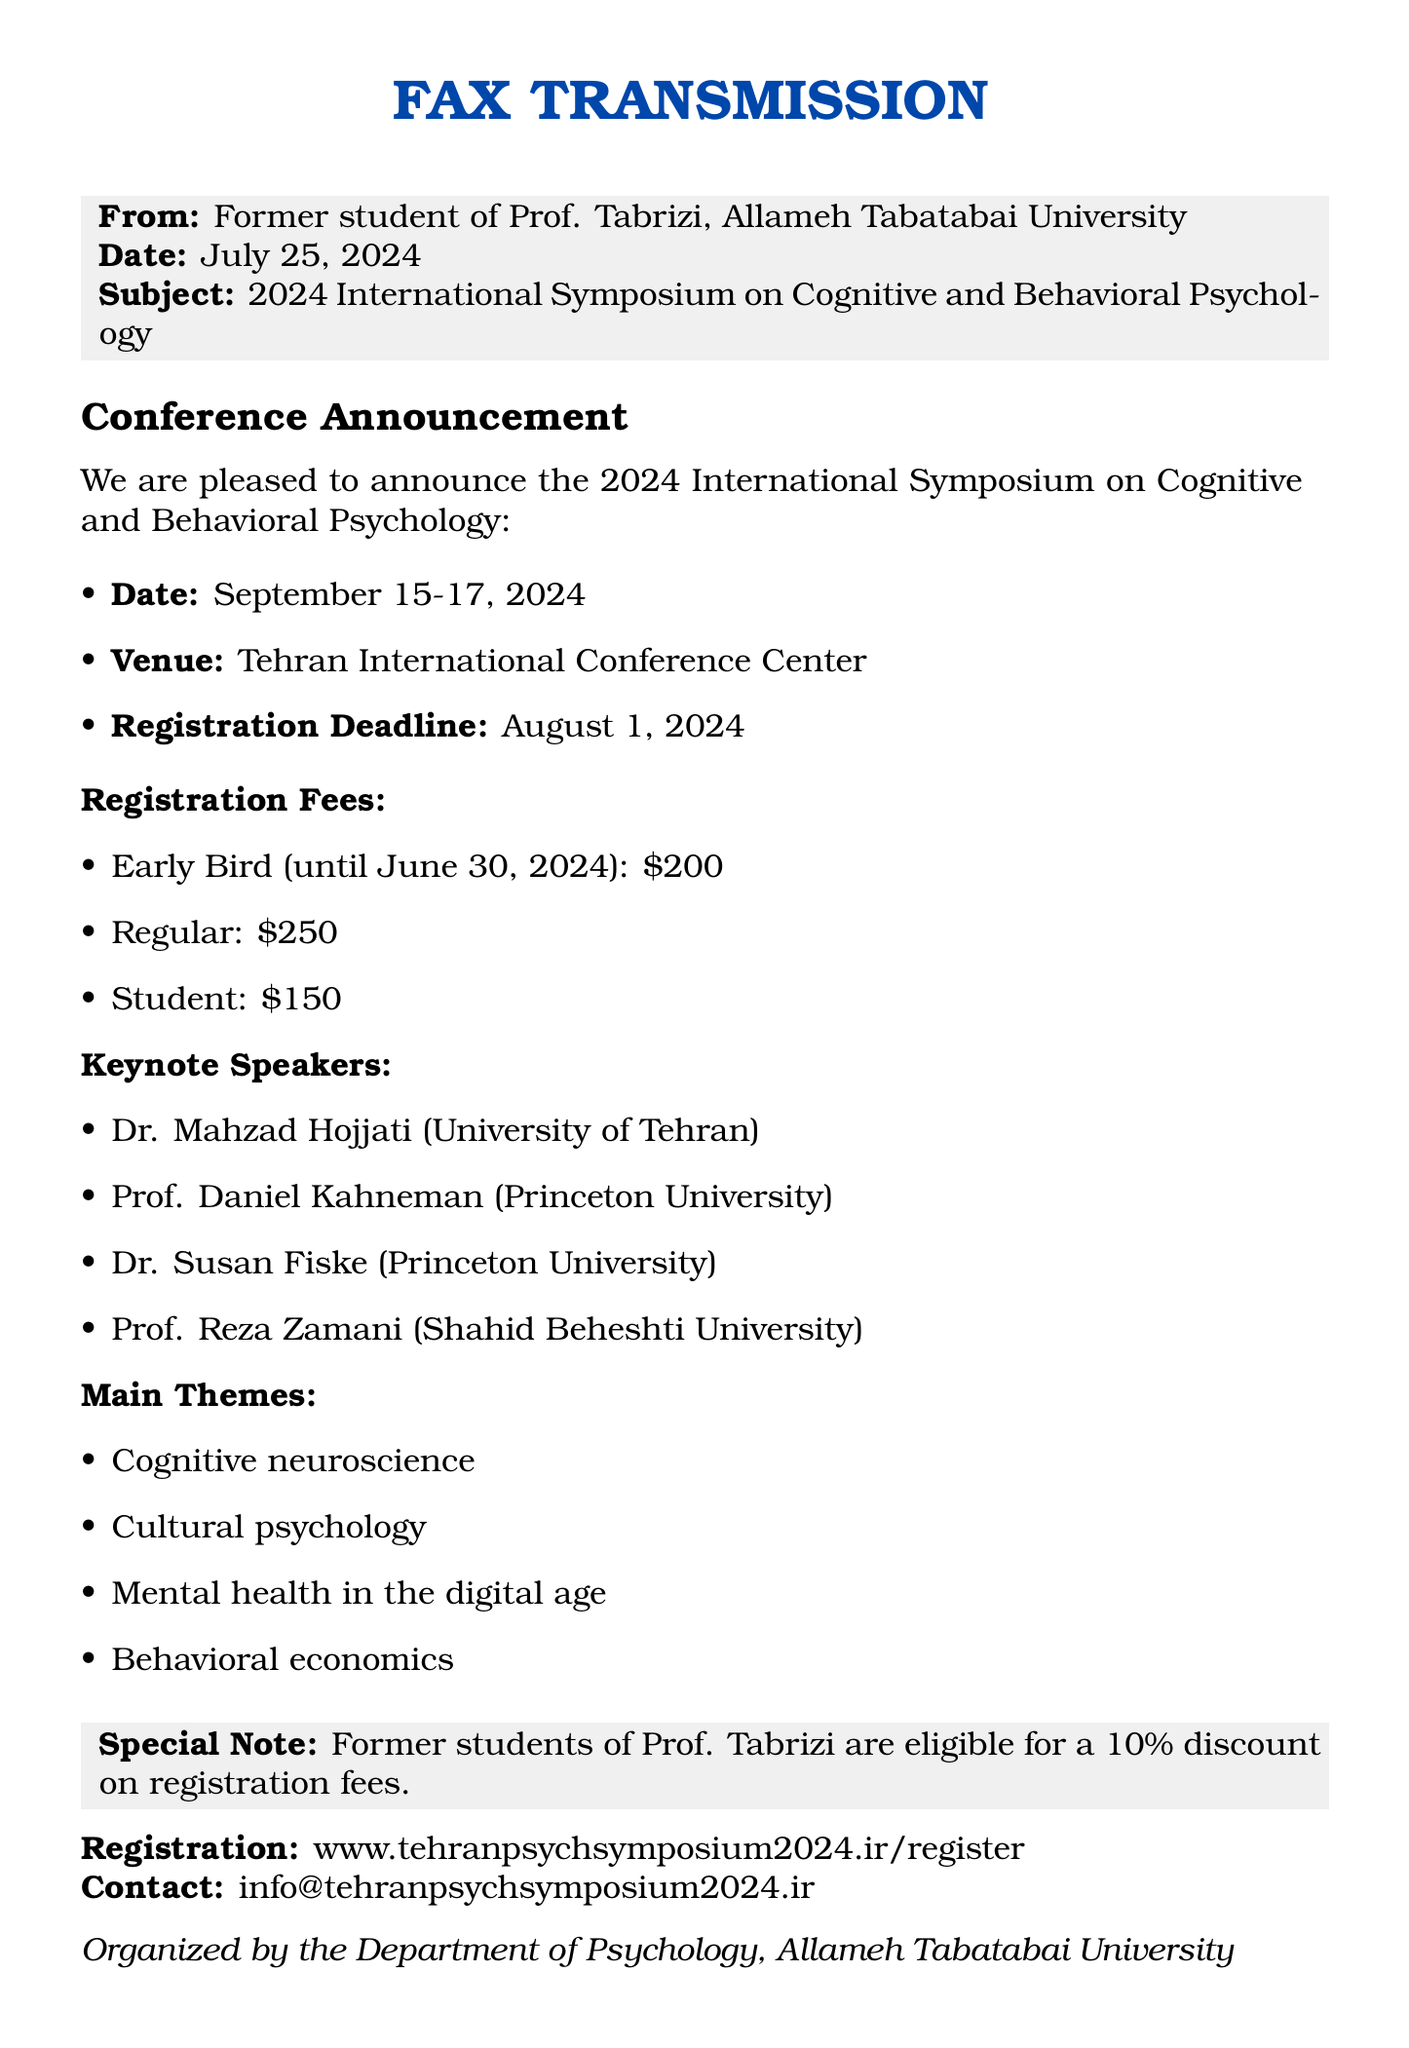what are the dates of the symposium? The symposium is scheduled for September 15-17, 2024, as stated in the document.
Answer: September 15-17, 2024 where is the symposium being held? The venue for the symposium is mentioned as the Tehran International Conference Center.
Answer: Tehran International Conference Center what is the early bird registration fee? The document specifies that the early bird registration fee is $200 until June 30, 2024.
Answer: $200 who is one of the keynote speakers? The document lists several keynote speakers, one being Prof. Daniel Kahneman from Princeton University.
Answer: Prof. Daniel Kahneman what discount do former students of Prof. Tabrizi receive? The document explicitly states that former students of Prof. Tabrizi are eligible for a 10% discount on registration fees.
Answer: 10% what is the registration deadline? The registration deadline is clearly stated as August 1, 2024, in the document.
Answer: August 1, 2024 what are the main themes of the symposium? The document lists main themes such as cognitive neuroscience, among others, indicating the areas of focus for the symposium.
Answer: Cognitive neuroscience how can one register for the symposium? The registration information provides a website to visit for registration: www.tehranpsychsymposium2024.ir/register.
Answer: www.tehranpsychsymposium2024.ir/register 